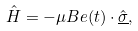<formula> <loc_0><loc_0><loc_500><loc_500>\hat { H } = - \mu B { e } ( t ) \cdot { \underline { \hat { \sigma } } } ,</formula> 